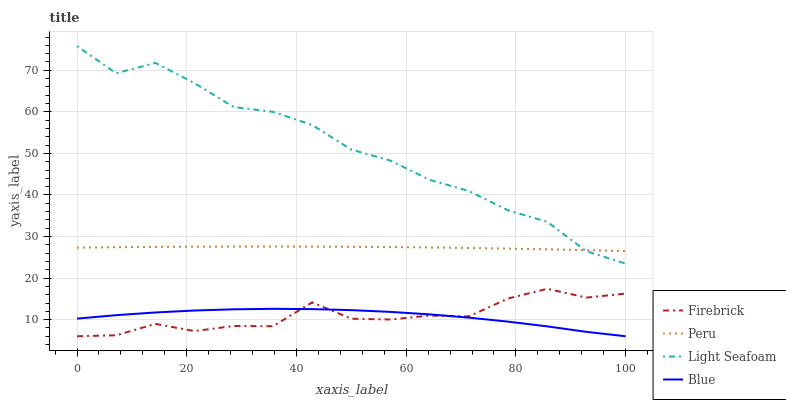Does Blue have the minimum area under the curve?
Answer yes or no. Yes. Does Light Seafoam have the maximum area under the curve?
Answer yes or no. Yes. Does Firebrick have the minimum area under the curve?
Answer yes or no. No. Does Firebrick have the maximum area under the curve?
Answer yes or no. No. Is Peru the smoothest?
Answer yes or no. Yes. Is Firebrick the roughest?
Answer yes or no. Yes. Is Light Seafoam the smoothest?
Answer yes or no. No. Is Light Seafoam the roughest?
Answer yes or no. No. Does Blue have the lowest value?
Answer yes or no. Yes. Does Light Seafoam have the lowest value?
Answer yes or no. No. Does Light Seafoam have the highest value?
Answer yes or no. Yes. Does Firebrick have the highest value?
Answer yes or no. No. Is Blue less than Light Seafoam?
Answer yes or no. Yes. Is Light Seafoam greater than Blue?
Answer yes or no. Yes. Does Blue intersect Firebrick?
Answer yes or no. Yes. Is Blue less than Firebrick?
Answer yes or no. No. Is Blue greater than Firebrick?
Answer yes or no. No. Does Blue intersect Light Seafoam?
Answer yes or no. No. 